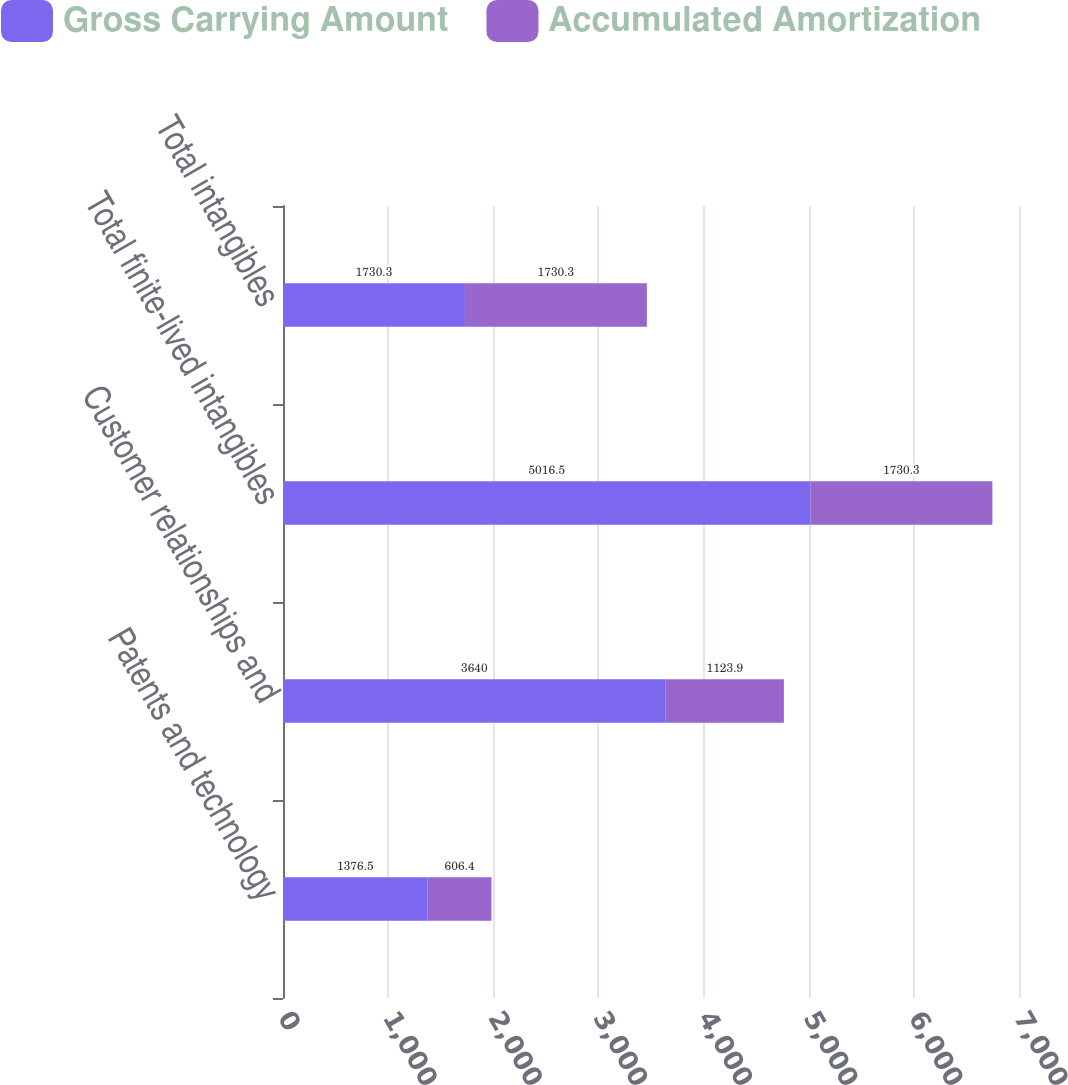Convert chart. <chart><loc_0><loc_0><loc_500><loc_500><stacked_bar_chart><ecel><fcel>Patents and technology<fcel>Customer relationships and<fcel>Total finite-lived intangibles<fcel>Total intangibles<nl><fcel>Gross Carrying Amount<fcel>1376.5<fcel>3640<fcel>5016.5<fcel>1730.3<nl><fcel>Accumulated Amortization<fcel>606.4<fcel>1123.9<fcel>1730.3<fcel>1730.3<nl></chart> 